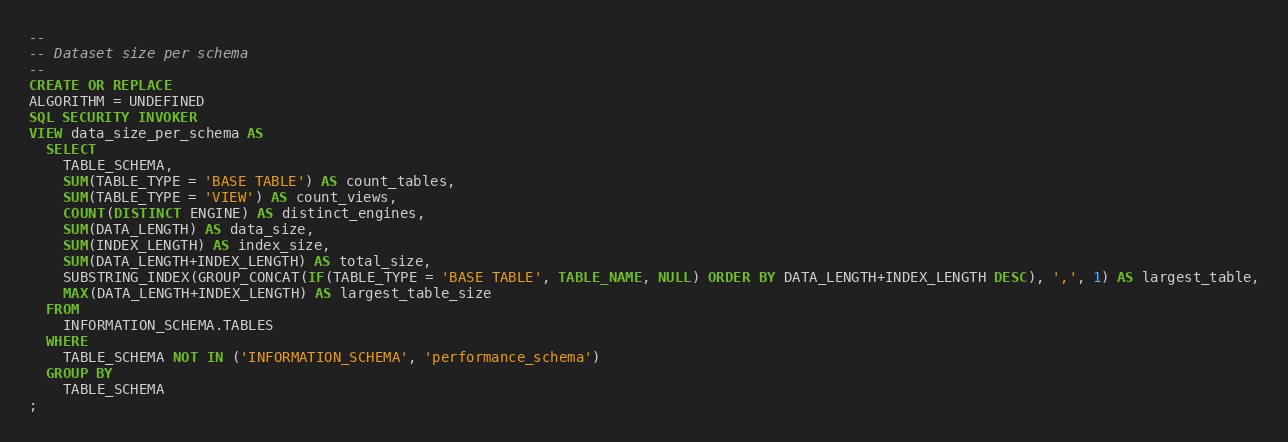<code> <loc_0><loc_0><loc_500><loc_500><_SQL_>-- 
-- Dataset size per schema
-- 
CREATE OR REPLACE
ALGORITHM = UNDEFINED
SQL SECURITY INVOKER
VIEW data_size_per_schema AS
  SELECT 
    TABLE_SCHEMA, 
    SUM(TABLE_TYPE = 'BASE TABLE') AS count_tables,
    SUM(TABLE_TYPE = 'VIEW') AS count_views,
    COUNT(DISTINCT ENGINE) AS distinct_engines,
    SUM(DATA_LENGTH) AS data_size,
    SUM(INDEX_LENGTH) AS index_size,
    SUM(DATA_LENGTH+INDEX_LENGTH) AS total_size,
    SUBSTRING_INDEX(GROUP_CONCAT(IF(TABLE_TYPE = 'BASE TABLE', TABLE_NAME, NULL) ORDER BY DATA_LENGTH+INDEX_LENGTH DESC), ',', 1) AS largest_table,
    MAX(DATA_LENGTH+INDEX_LENGTH) AS largest_table_size
  FROM 
    INFORMATION_SCHEMA.TABLES
  WHERE 
    TABLE_SCHEMA NOT IN ('INFORMATION_SCHEMA', 'performance_schema')
  GROUP BY 
    TABLE_SCHEMA
;
</code> 